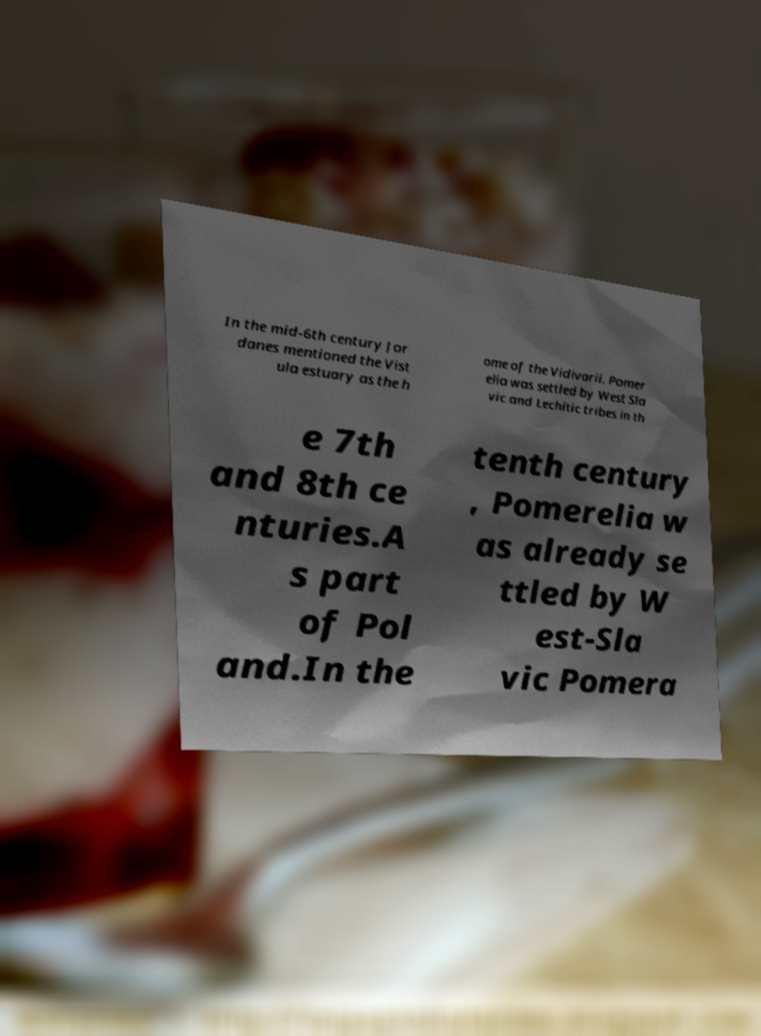Please identify and transcribe the text found in this image. In the mid-6th century Jor danes mentioned the Vist ula estuary as the h ome of the Vidivarii. Pomer elia was settled by West Sla vic and Lechitic tribes in th e 7th and 8th ce nturies.A s part of Pol and.In the tenth century , Pomerelia w as already se ttled by W est-Sla vic Pomera 